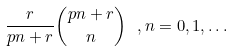Convert formula to latex. <formula><loc_0><loc_0><loc_500><loc_500>\frac { r } { p n + r } \binom { p n + r } { n } \ , n = 0 , 1 , \dots</formula> 